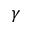<formula> <loc_0><loc_0><loc_500><loc_500>\gamma</formula> 